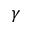<formula> <loc_0><loc_0><loc_500><loc_500>\gamma</formula> 